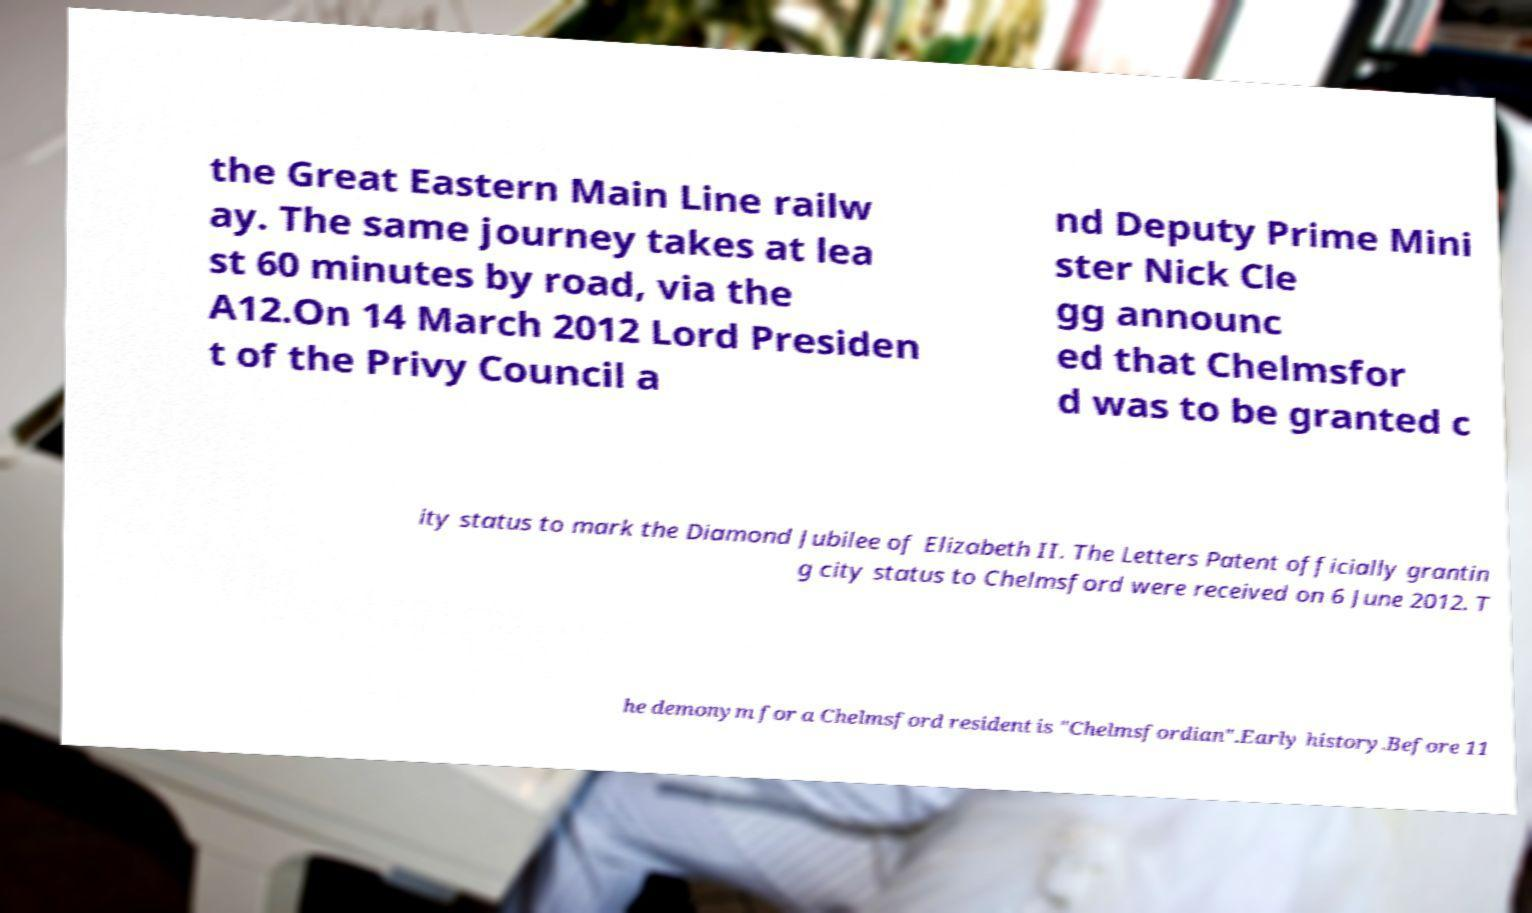There's text embedded in this image that I need extracted. Can you transcribe it verbatim? the Great Eastern Main Line railw ay. The same journey takes at lea st 60 minutes by road, via the A12.On 14 March 2012 Lord Presiden t of the Privy Council a nd Deputy Prime Mini ster Nick Cle gg announc ed that Chelmsfor d was to be granted c ity status to mark the Diamond Jubilee of Elizabeth II. The Letters Patent officially grantin g city status to Chelmsford were received on 6 June 2012. T he demonym for a Chelmsford resident is "Chelmsfordian".Early history.Before 11 